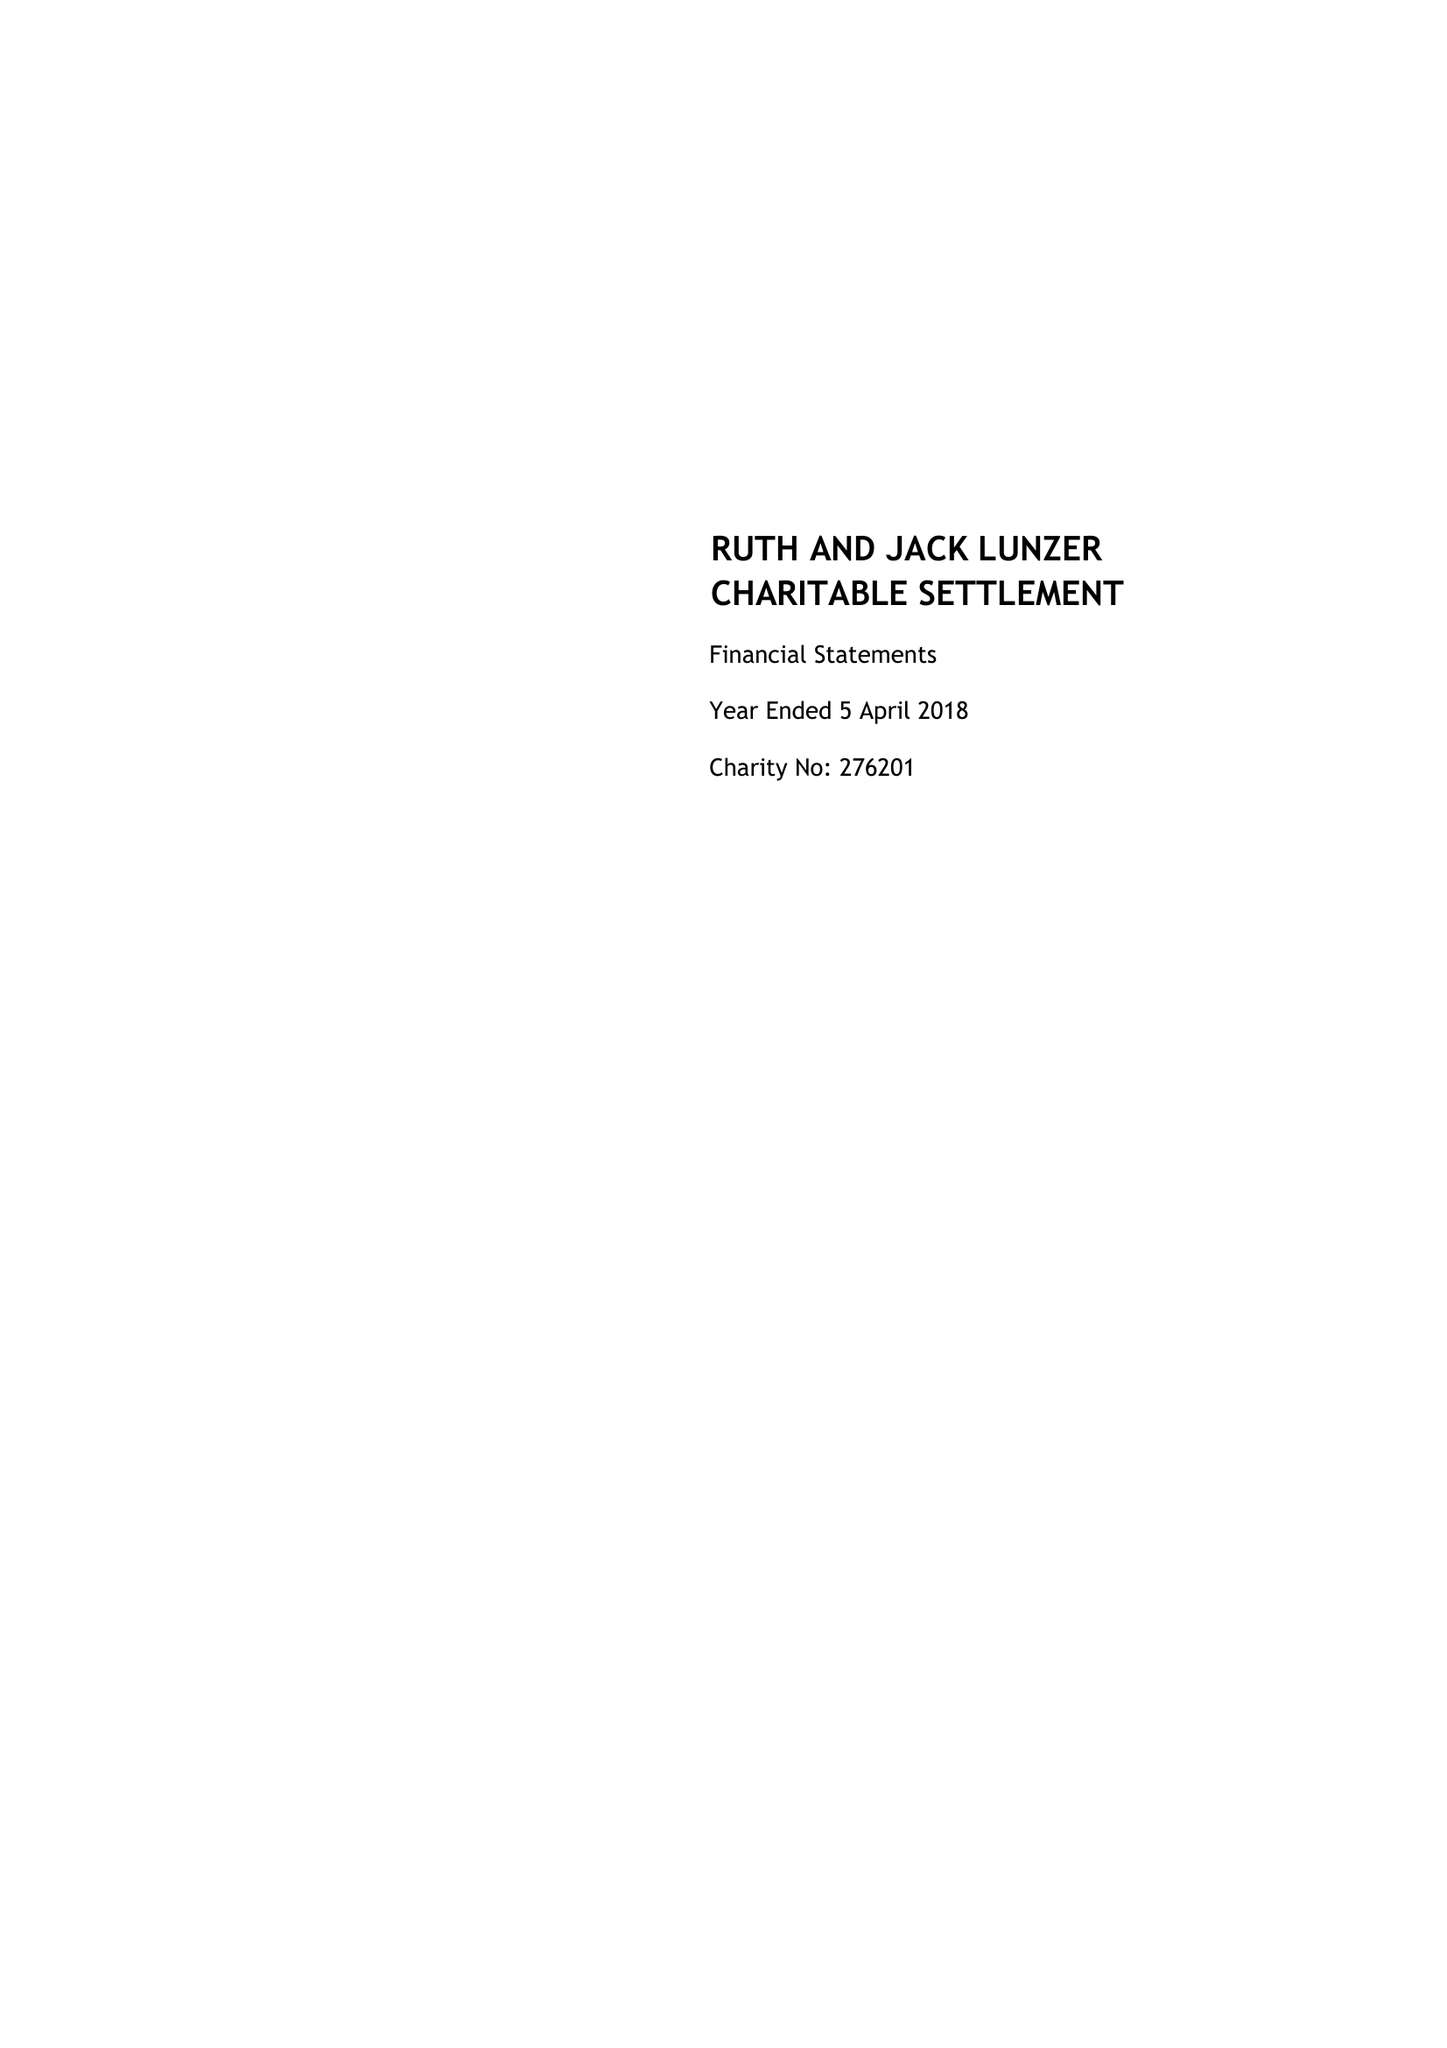What is the value for the report_date?
Answer the question using a single word or phrase. 2018-04-05 